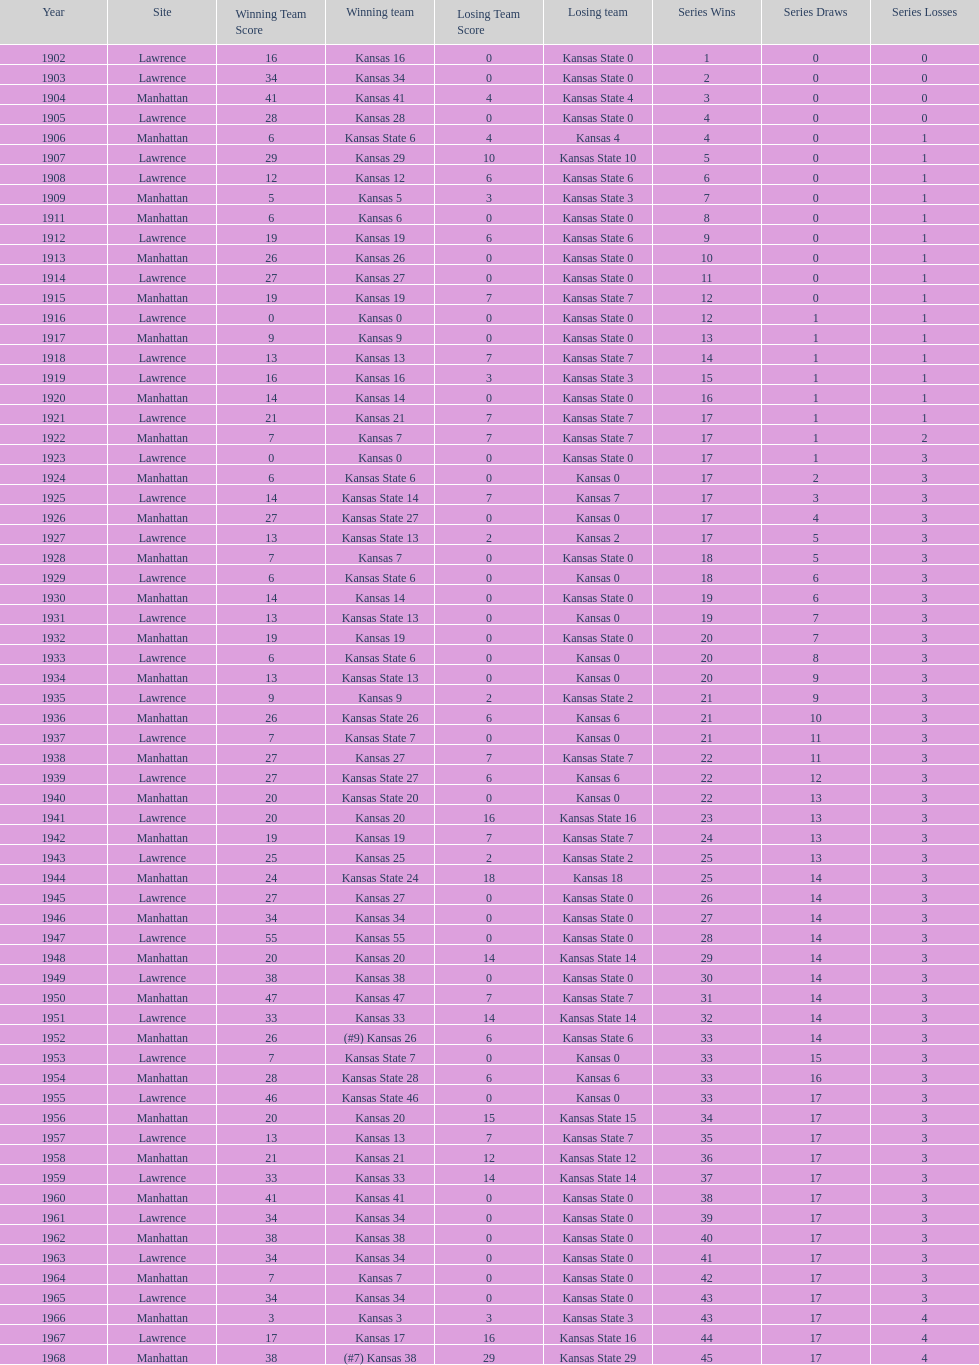Who had the most wins in the 1950's: kansas or kansas state? Kansas. 